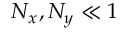<formula> <loc_0><loc_0><loc_500><loc_500>N _ { x } , N _ { y } \ll 1</formula> 